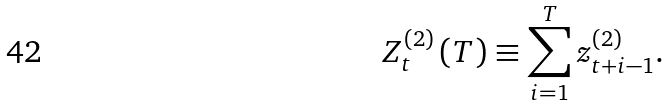<formula> <loc_0><loc_0><loc_500><loc_500>Z _ { t } ^ { \left ( 2 \right ) } \left ( T \right ) \equiv \sum _ { i = 1 } ^ { T } z _ { t + i - 1 } ^ { \left ( 2 \right ) } .</formula> 